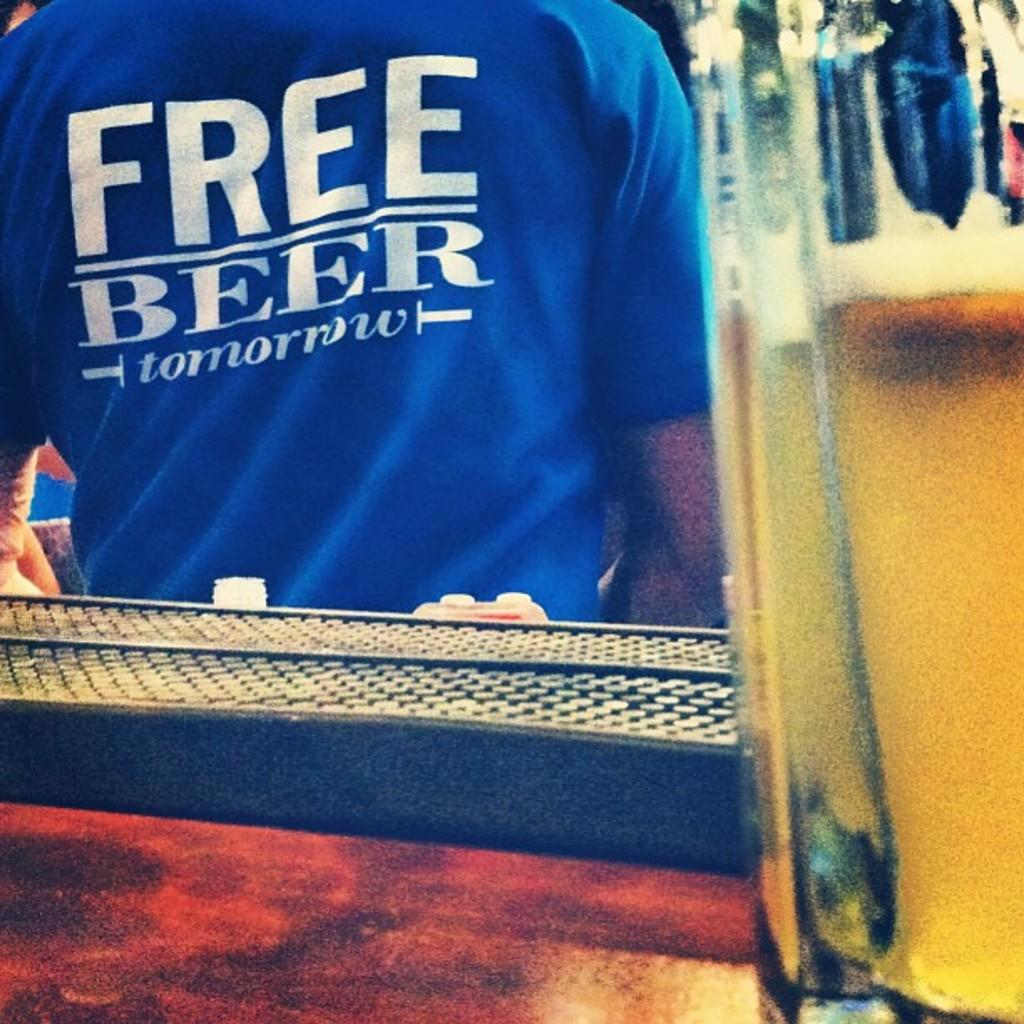<image>
Offer a succinct explanation of the picture presented. Bar including a man wearing a free beer t shirt 